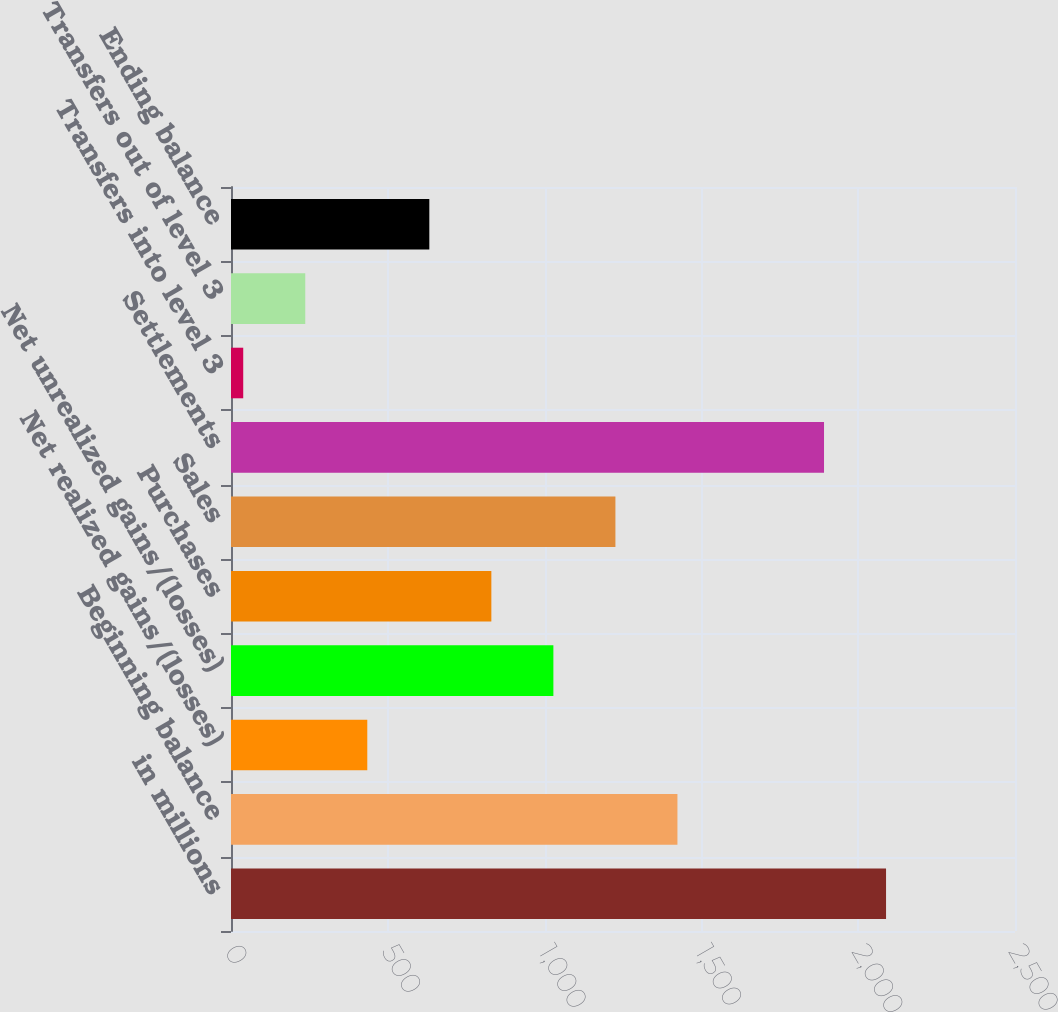Convert chart. <chart><loc_0><loc_0><loc_500><loc_500><bar_chart><fcel>in millions<fcel>Beginning balance<fcel>Net realized gains/(losses)<fcel>Net unrealized gains/(losses)<fcel>Purchases<fcel>Sales<fcel>Settlements<fcel>Transfers into level 3<fcel>Transfers out of level 3<fcel>Ending balance<nl><fcel>2088.8<fcel>1423.6<fcel>434.6<fcel>1028<fcel>830.2<fcel>1225.8<fcel>1891<fcel>39<fcel>236.8<fcel>632.4<nl></chart> 